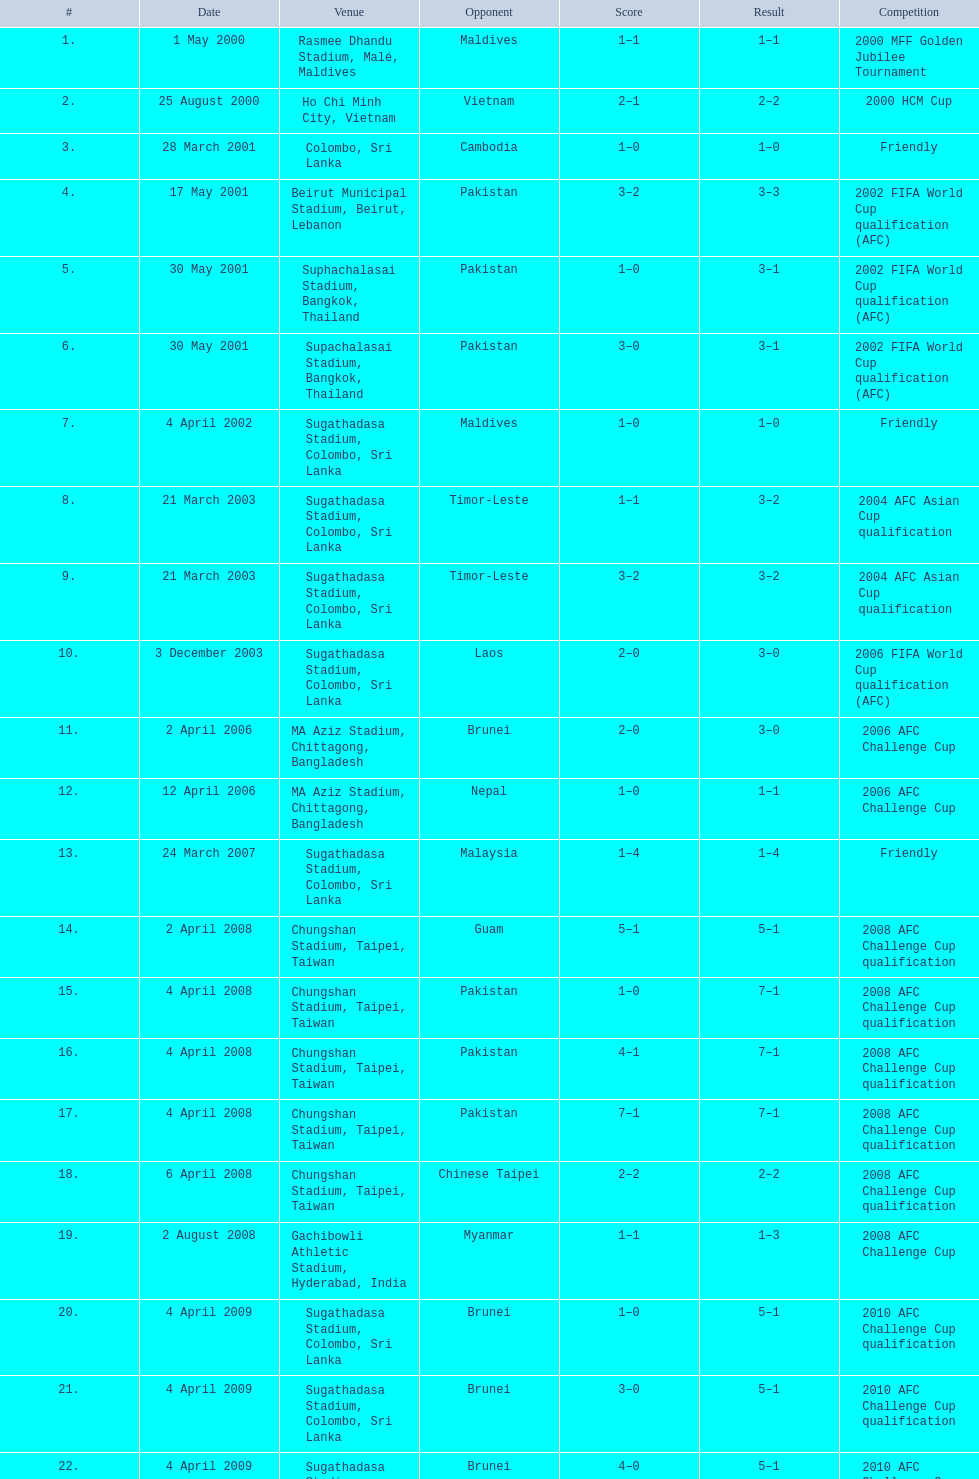How often was laos the opposing team? 1. 